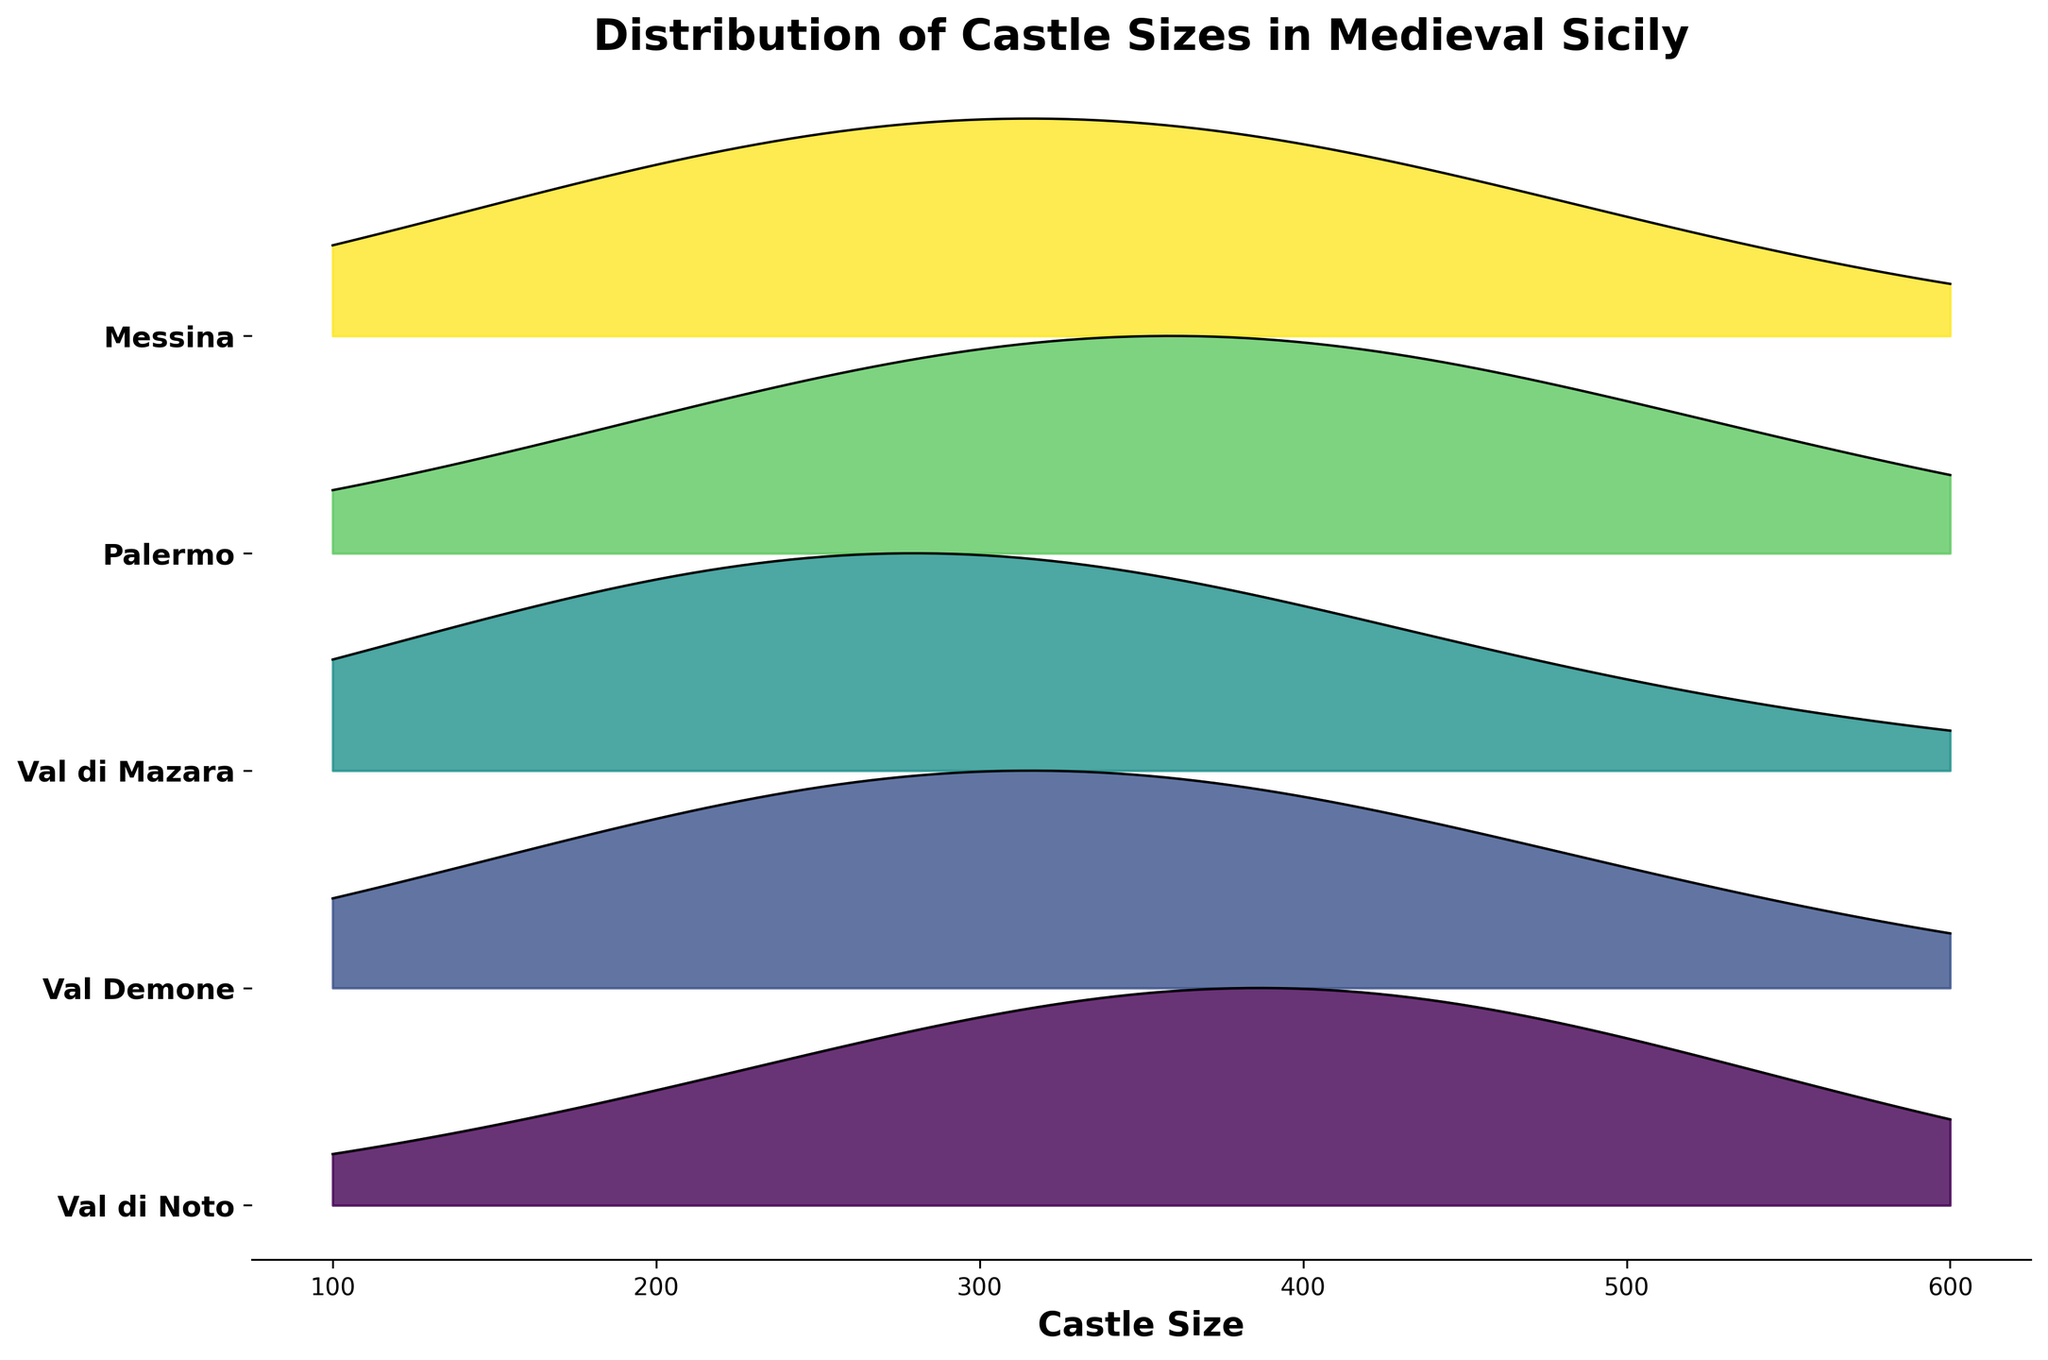What is the title of the plot? The title of the plot is displayed at the top and it reads "Distribution of Castle Sizes in Medieval Sicily".
Answer: Distribution of Castle Sizes in Medieval Sicily Which region has the highest peak in the distribution of castle sizes? By observing the highest points on the plot for each ridgeline, Val di Mazara has the highest peak in the distribution of castle sizes.
Answer: Val di Mazara What is the range of castle sizes depicted in the plot? The plot's x-axis represents castle sizes, which range from 100 to 600.
Answer: 100 to 600 Which region has a notable peak at around 200 in the castle size distribution? Looking at the position of the peaks around the 200 mark on the x-axis, Val di Mazara has a notable peak.
Answer: Val di Mazara How do the distributions of castle sizes in Palermo and Messina compare around 300? Comparing the plot lines around 300 on the x-axis, both Palermo and Messina show similar frequencies with a moderate peak.
Answer: Similar frequencies with a moderate peak Which region shows the most diverse distribution of castle sizes? Regions with broader or multiple peaks indicate more diversity. Val di Noto shows a more diverse distribution compared to others.
Answer: Val di Noto Which region shows the least frequency for castles in the size range of 100-200? Observing the lower portion of the ridgelines from 100 to 200, Val di Noto has the least frequency in this range.
Answer: Val di Noto Which region has more significant peaks for castle sizes above 400? Looking at the peaks above 400 on the x-axis, Palermo demonstrates more prominent peaks compared to other regions.
Answer: Palermo 